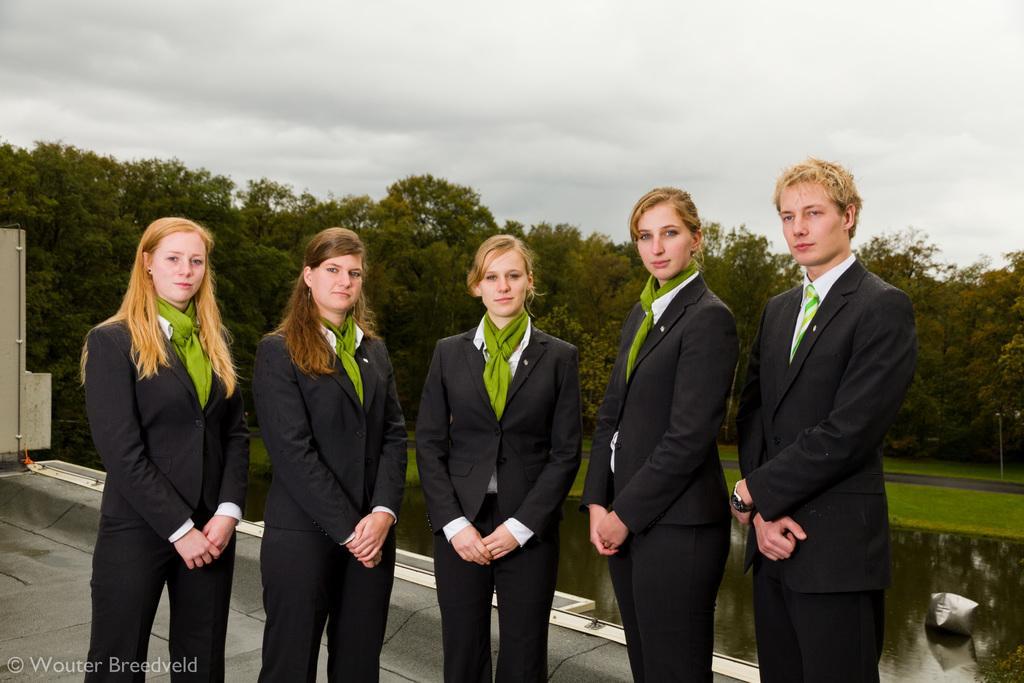How would you summarize this image in a sentence or two? In this image there are four girls who are wearing the suit are standing on the floor. On the right side there is a man. In the background there are trees. At the top there is the sky. Behind them there is a wall. 